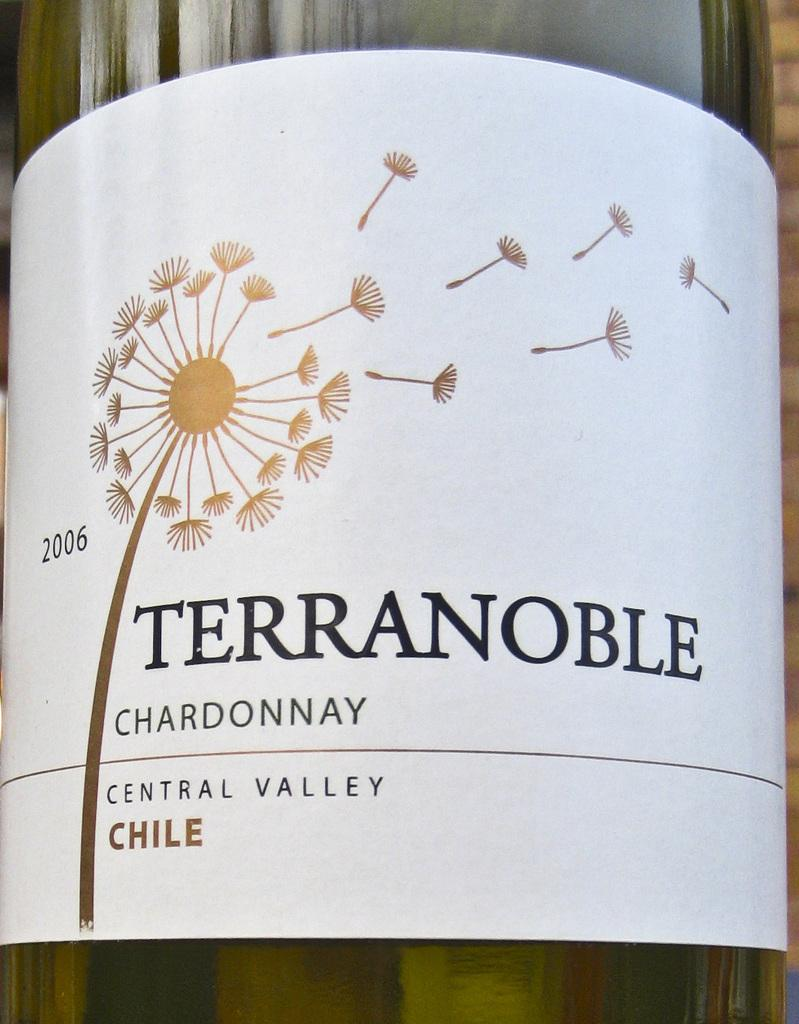<image>
Provide a brief description of the given image. A bottle of Terranoble chardonnay has a dandelion on the label. 